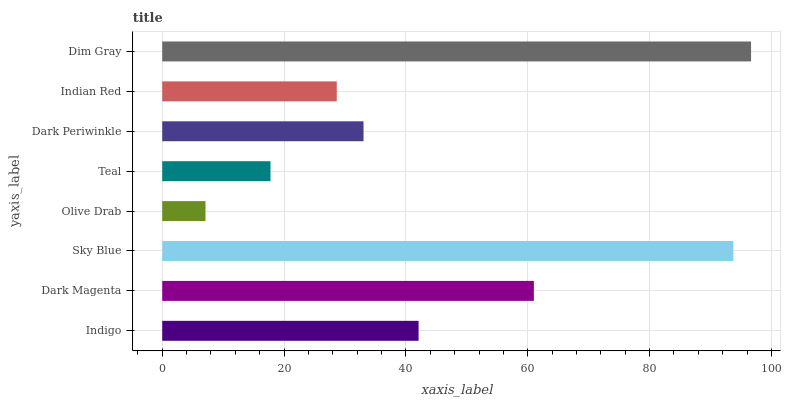Is Olive Drab the minimum?
Answer yes or no. Yes. Is Dim Gray the maximum?
Answer yes or no. Yes. Is Dark Magenta the minimum?
Answer yes or no. No. Is Dark Magenta the maximum?
Answer yes or no. No. Is Dark Magenta greater than Indigo?
Answer yes or no. Yes. Is Indigo less than Dark Magenta?
Answer yes or no. Yes. Is Indigo greater than Dark Magenta?
Answer yes or no. No. Is Dark Magenta less than Indigo?
Answer yes or no. No. Is Indigo the high median?
Answer yes or no. Yes. Is Dark Periwinkle the low median?
Answer yes or no. Yes. Is Sky Blue the high median?
Answer yes or no. No. Is Teal the low median?
Answer yes or no. No. 